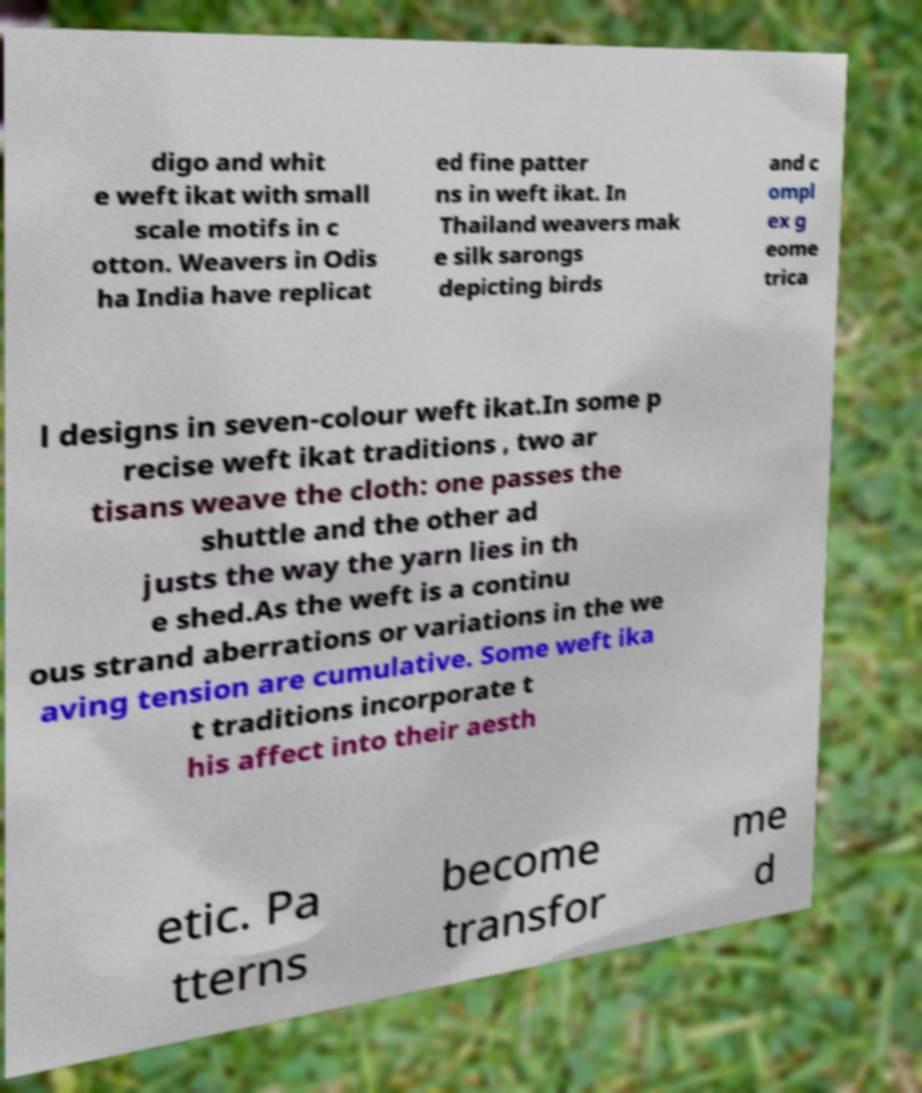Can you read and provide the text displayed in the image?This photo seems to have some interesting text. Can you extract and type it out for me? digo and whit e weft ikat with small scale motifs in c otton. Weavers in Odis ha India have replicat ed fine patter ns in weft ikat. In Thailand weavers mak e silk sarongs depicting birds and c ompl ex g eome trica l designs in seven-colour weft ikat.In some p recise weft ikat traditions , two ar tisans weave the cloth: one passes the shuttle and the other ad justs the way the yarn lies in th e shed.As the weft is a continu ous strand aberrations or variations in the we aving tension are cumulative. Some weft ika t traditions incorporate t his affect into their aesth etic. Pa tterns become transfor me d 